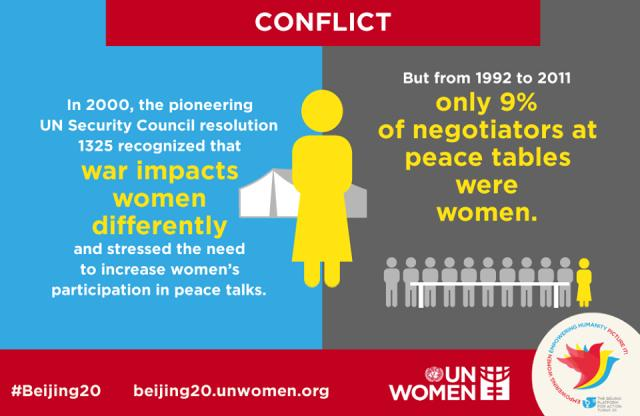Draw attention to some important aspects in this diagram. The United Nations Security Council, in its Resolution 1325, stressed the importance of increasing women's participation in peace talks. If we assume that there were 100 negotiators working on the Kyoto Protocol between 1992 and 2011, and that 9% of them were women, based on the analysis made. The female shown is depicted as having a yellow color. 